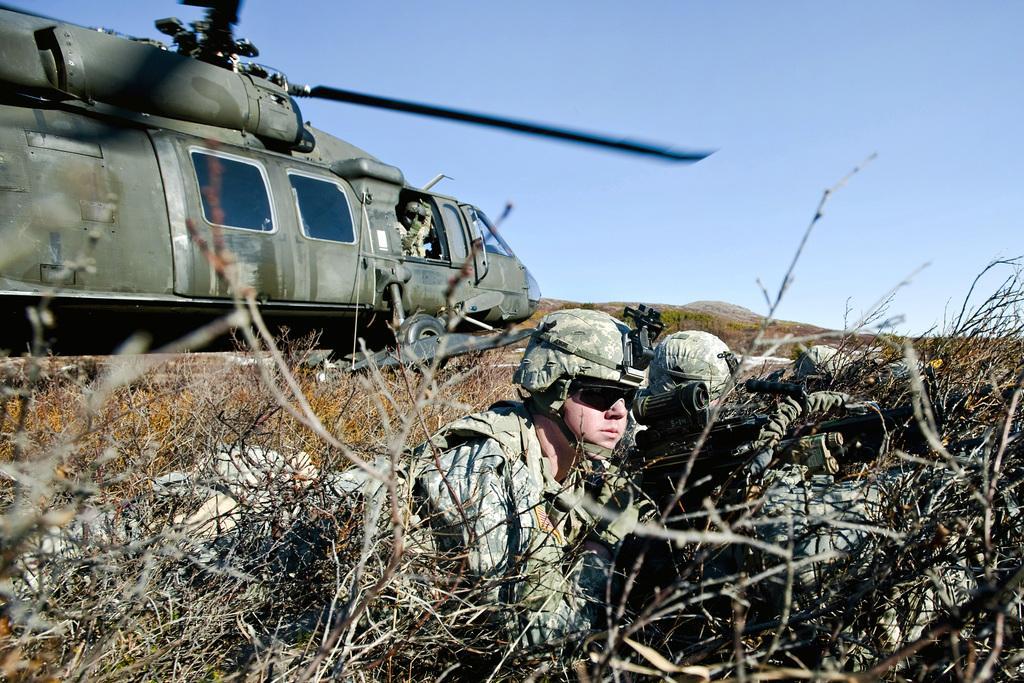Describe this image in one or two sentences. In this picture we can see some people hiding behind the dried plants. Behind the people there is a military helicopter. On the right side of the helicopter there is a small hill and the sky. 